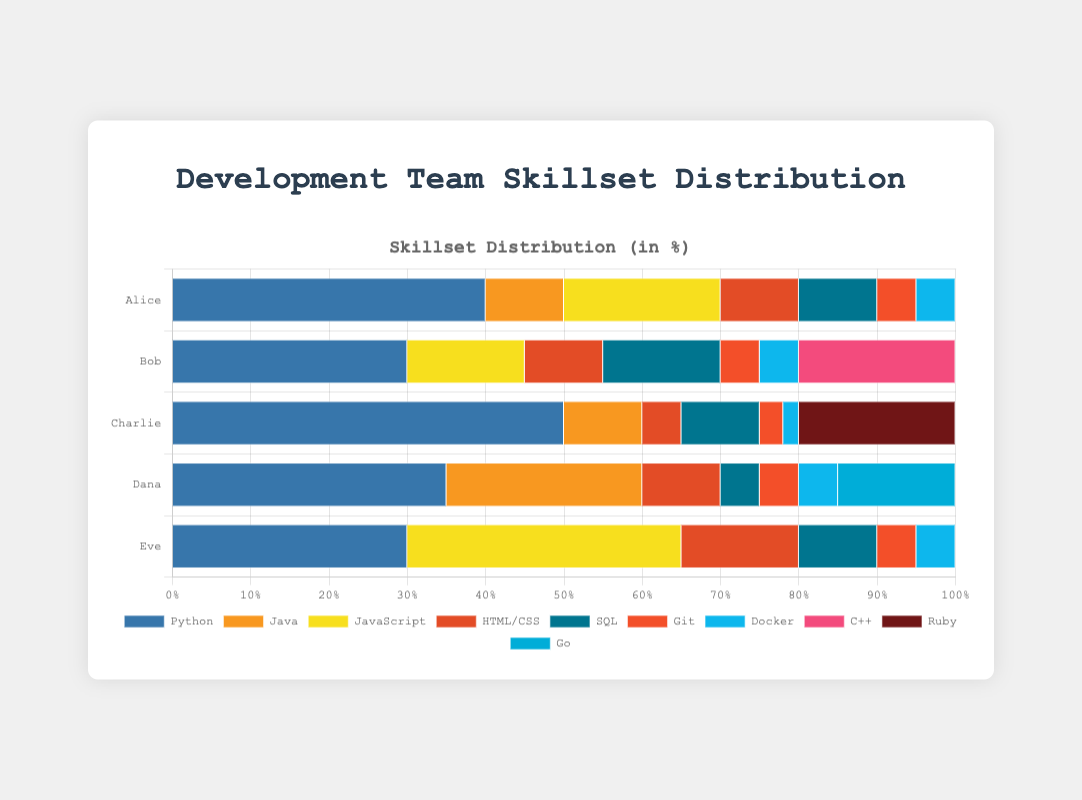Which team member has the highest percentage of Python skills? By visually inspecting the lengths of the Python (blue) bars for each team member, Charlie has the longest blue bar. This indicates he has the highest percentage of Python skills at 50%.
Answer: Charlie Which programming language or tool has the least representation across the team? By observing the overall distribution of colors, Docker has the least representation since its sections in each bar are the smallest across the team members.
Answer: Docker What is the total percentage of Java skills in the team? Summing up the Java percentages across all members: Alice (10) + Charlie (10) + Dana (25) = 45. Bob and Eve do not have Java skills. Therefore, the total percentage is 45%.
Answer: 45% Which two team members have the most similar skill distribution? By comparing the visual patterns of the bars, Bob and Eve seem to have a similar distribution and percentage of skills in Python, JavaScript, HTML/CSS, SQL, Git, and Docker. Both have visible major segments in Python and JavaScript.
Answer: Bob and Eve Who has the largest proportion of JavaScript skills? Comparing the length of the JavaScript (yellow) bar segments, Eve's JavaScript segment is the longest at 35%.
Answer: Eve What is the average percentage of HTML/CSS skills in the team? Sum the HTML/CSS percentages of all members and then divide by the number of team members: (Alice 10 + Bob 10 + Charlie 5 + Dana 10 + Eve 15) / 5 = 50 / 5 = 10%.
Answer: 10% Compare the total percentage of SQL skills to Python skills within the team. Which is higher? Summing the SQL percentages: Alice (10) + Bob (15) + Charlie (10) + Dana (5) + Eve (10) = 50%. Summing the Python percentages: Alice (40) + Bob (30) + Charlie (50) + Dana (35) + Eve (30) = 185%. Therefore, Python has a higher total percentage.
Answer: Python If you add up all Git and Docker skills, what is the total percentage? Each team member has 5% Git and 5% Docker, except Charlie who has 3% Git and 2% Docker. Therefore, total = (5 + 5) * 4 + (3 + 2) = 40 + 5 = 45%.
Answer: 45% Which team member has the lowest percentage of diversified skills? By analyzing the number of different skills represented and their variance in percentages, Charlie's skills are less diversified, heavily skewed towards Python (50%), with all other skills having lower percentages (10% or less).
Answer: Charlie 